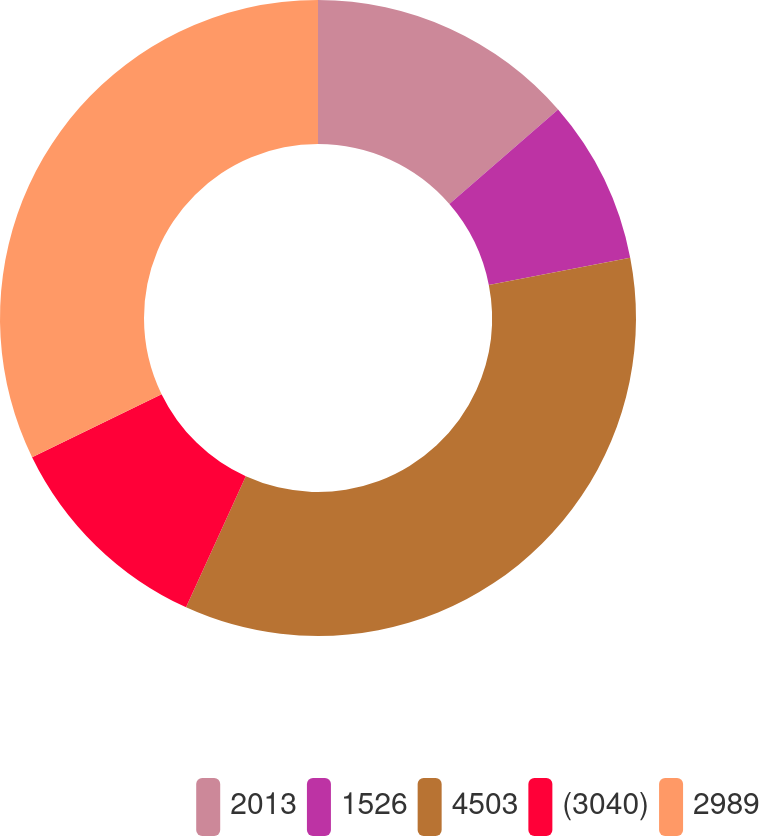Convert chart. <chart><loc_0><loc_0><loc_500><loc_500><pie_chart><fcel>2013<fcel>1526<fcel>4503<fcel>(3040)<fcel>2989<nl><fcel>13.62%<fcel>8.34%<fcel>34.85%<fcel>10.98%<fcel>32.21%<nl></chart> 